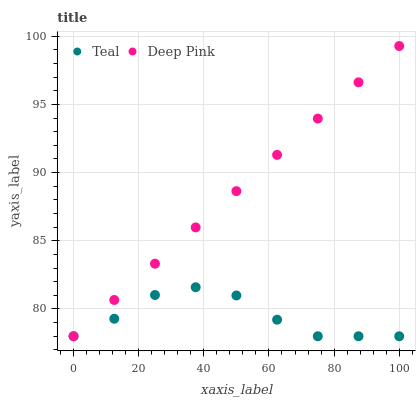Does Teal have the minimum area under the curve?
Answer yes or no. Yes. Does Deep Pink have the maximum area under the curve?
Answer yes or no. Yes. Does Teal have the maximum area under the curve?
Answer yes or no. No. Is Deep Pink the smoothest?
Answer yes or no. Yes. Is Teal the roughest?
Answer yes or no. Yes. Is Teal the smoothest?
Answer yes or no. No. Does Deep Pink have the lowest value?
Answer yes or no. Yes. Does Deep Pink have the highest value?
Answer yes or no. Yes. Does Teal have the highest value?
Answer yes or no. No. Does Teal intersect Deep Pink?
Answer yes or no. Yes. Is Teal less than Deep Pink?
Answer yes or no. No. Is Teal greater than Deep Pink?
Answer yes or no. No. 